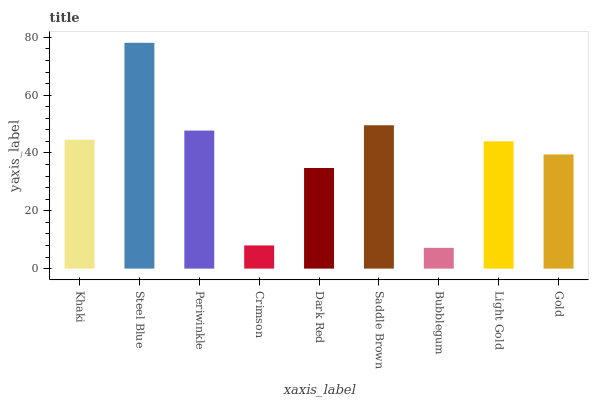Is Bubblegum the minimum?
Answer yes or no. Yes. Is Steel Blue the maximum?
Answer yes or no. Yes. Is Periwinkle the minimum?
Answer yes or no. No. Is Periwinkle the maximum?
Answer yes or no. No. Is Steel Blue greater than Periwinkle?
Answer yes or no. Yes. Is Periwinkle less than Steel Blue?
Answer yes or no. Yes. Is Periwinkle greater than Steel Blue?
Answer yes or no. No. Is Steel Blue less than Periwinkle?
Answer yes or no. No. Is Light Gold the high median?
Answer yes or no. Yes. Is Light Gold the low median?
Answer yes or no. Yes. Is Steel Blue the high median?
Answer yes or no. No. Is Gold the low median?
Answer yes or no. No. 